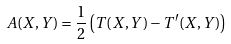<formula> <loc_0><loc_0><loc_500><loc_500>A ( X , Y ) = { \frac { 1 } { 2 } } \left ( T ( X , Y ) - T ^ { \prime } ( X , Y ) \right )</formula> 